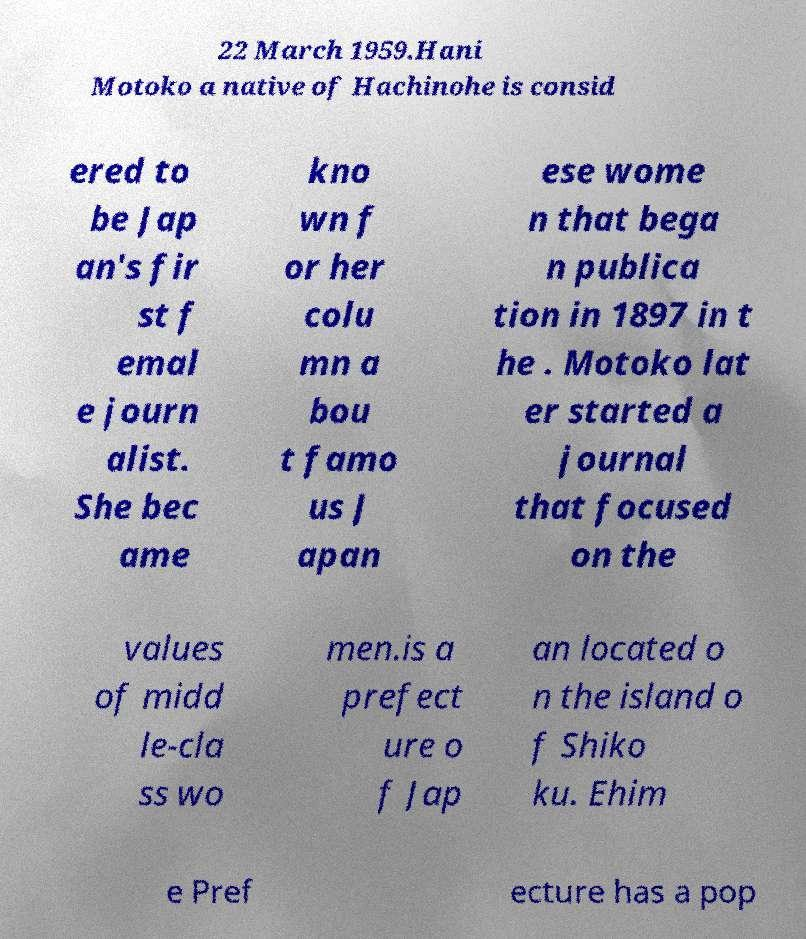What messages or text are displayed in this image? I need them in a readable, typed format. 22 March 1959.Hani Motoko a native of Hachinohe is consid ered to be Jap an's fir st f emal e journ alist. She bec ame kno wn f or her colu mn a bou t famo us J apan ese wome n that bega n publica tion in 1897 in t he . Motoko lat er started a journal that focused on the values of midd le-cla ss wo men.is a prefect ure o f Jap an located o n the island o f Shiko ku. Ehim e Pref ecture has a pop 